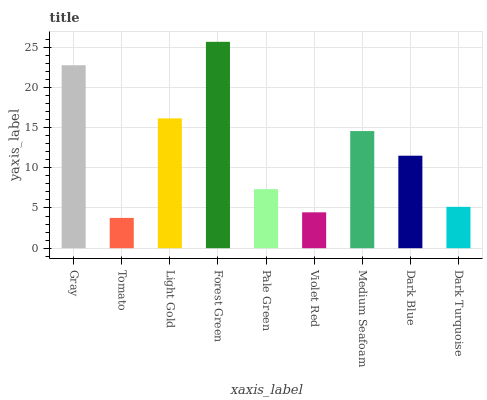Is Light Gold the minimum?
Answer yes or no. No. Is Light Gold the maximum?
Answer yes or no. No. Is Light Gold greater than Tomato?
Answer yes or no. Yes. Is Tomato less than Light Gold?
Answer yes or no. Yes. Is Tomato greater than Light Gold?
Answer yes or no. No. Is Light Gold less than Tomato?
Answer yes or no. No. Is Dark Blue the high median?
Answer yes or no. Yes. Is Dark Blue the low median?
Answer yes or no. Yes. Is Dark Turquoise the high median?
Answer yes or no. No. Is Gray the low median?
Answer yes or no. No. 